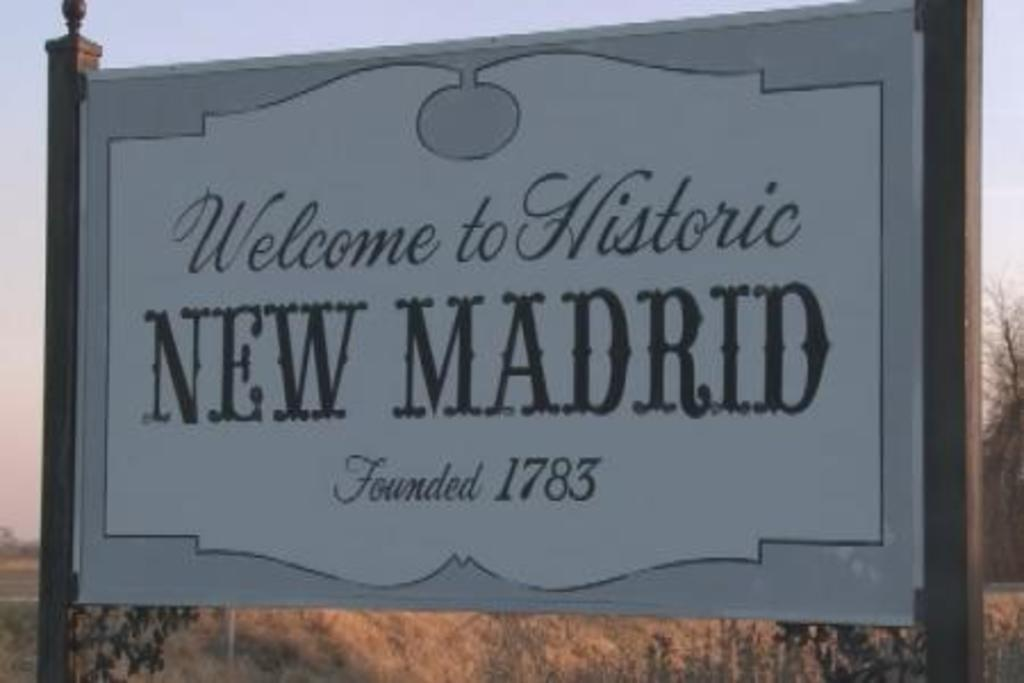Provide a one-sentence caption for the provided image. A sign saying "Welcome to New Madrid, Founded 1783". 